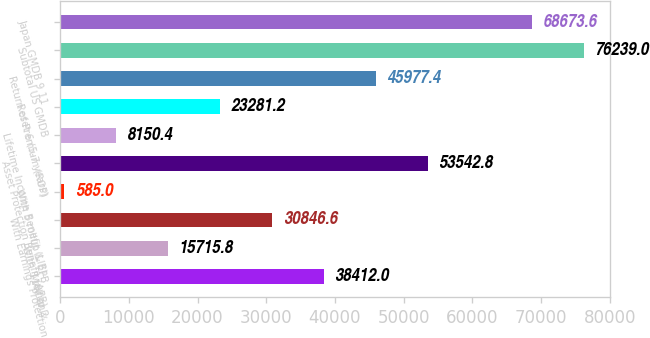<chart> <loc_0><loc_0><loc_500><loc_500><bar_chart><fcel>MAV only<fcel>With 5 rollup 2<fcel>With Earnings Protection<fcel>With 5 rollup & EPB<fcel>Asset Protection Benefit (APB)<fcel>Lifetime Income Benefit (LIB)-<fcel>Reset 6 (5-7 years)<fcel>Return of Premium (ROP)<fcel>Subtotal US GMDB<fcel>Japan GMDB 9 11<nl><fcel>38412<fcel>15715.8<fcel>30846.6<fcel>585<fcel>53542.8<fcel>8150.4<fcel>23281.2<fcel>45977.4<fcel>76239<fcel>68673.6<nl></chart> 